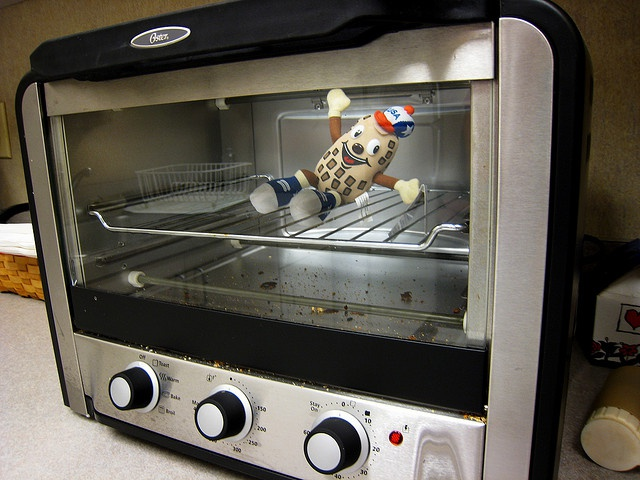Describe the objects in this image and their specific colors. I can see a oven in black, gray, darkgray, and darkgreen tones in this image. 